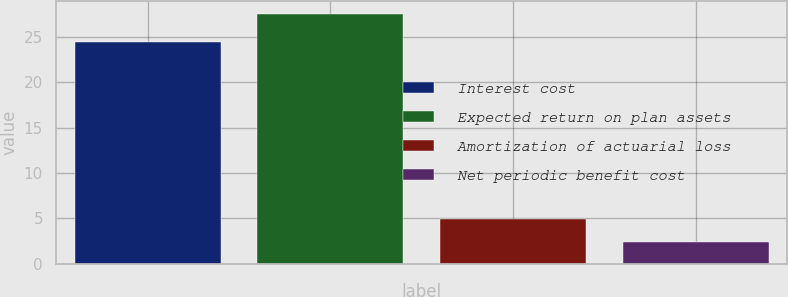Convert chart to OTSL. <chart><loc_0><loc_0><loc_500><loc_500><bar_chart><fcel>Interest cost<fcel>Expected return on plan assets<fcel>Amortization of actuarial loss<fcel>Net periodic benefit cost<nl><fcel>24.4<fcel>27.5<fcel>4.91<fcel>2.4<nl></chart> 